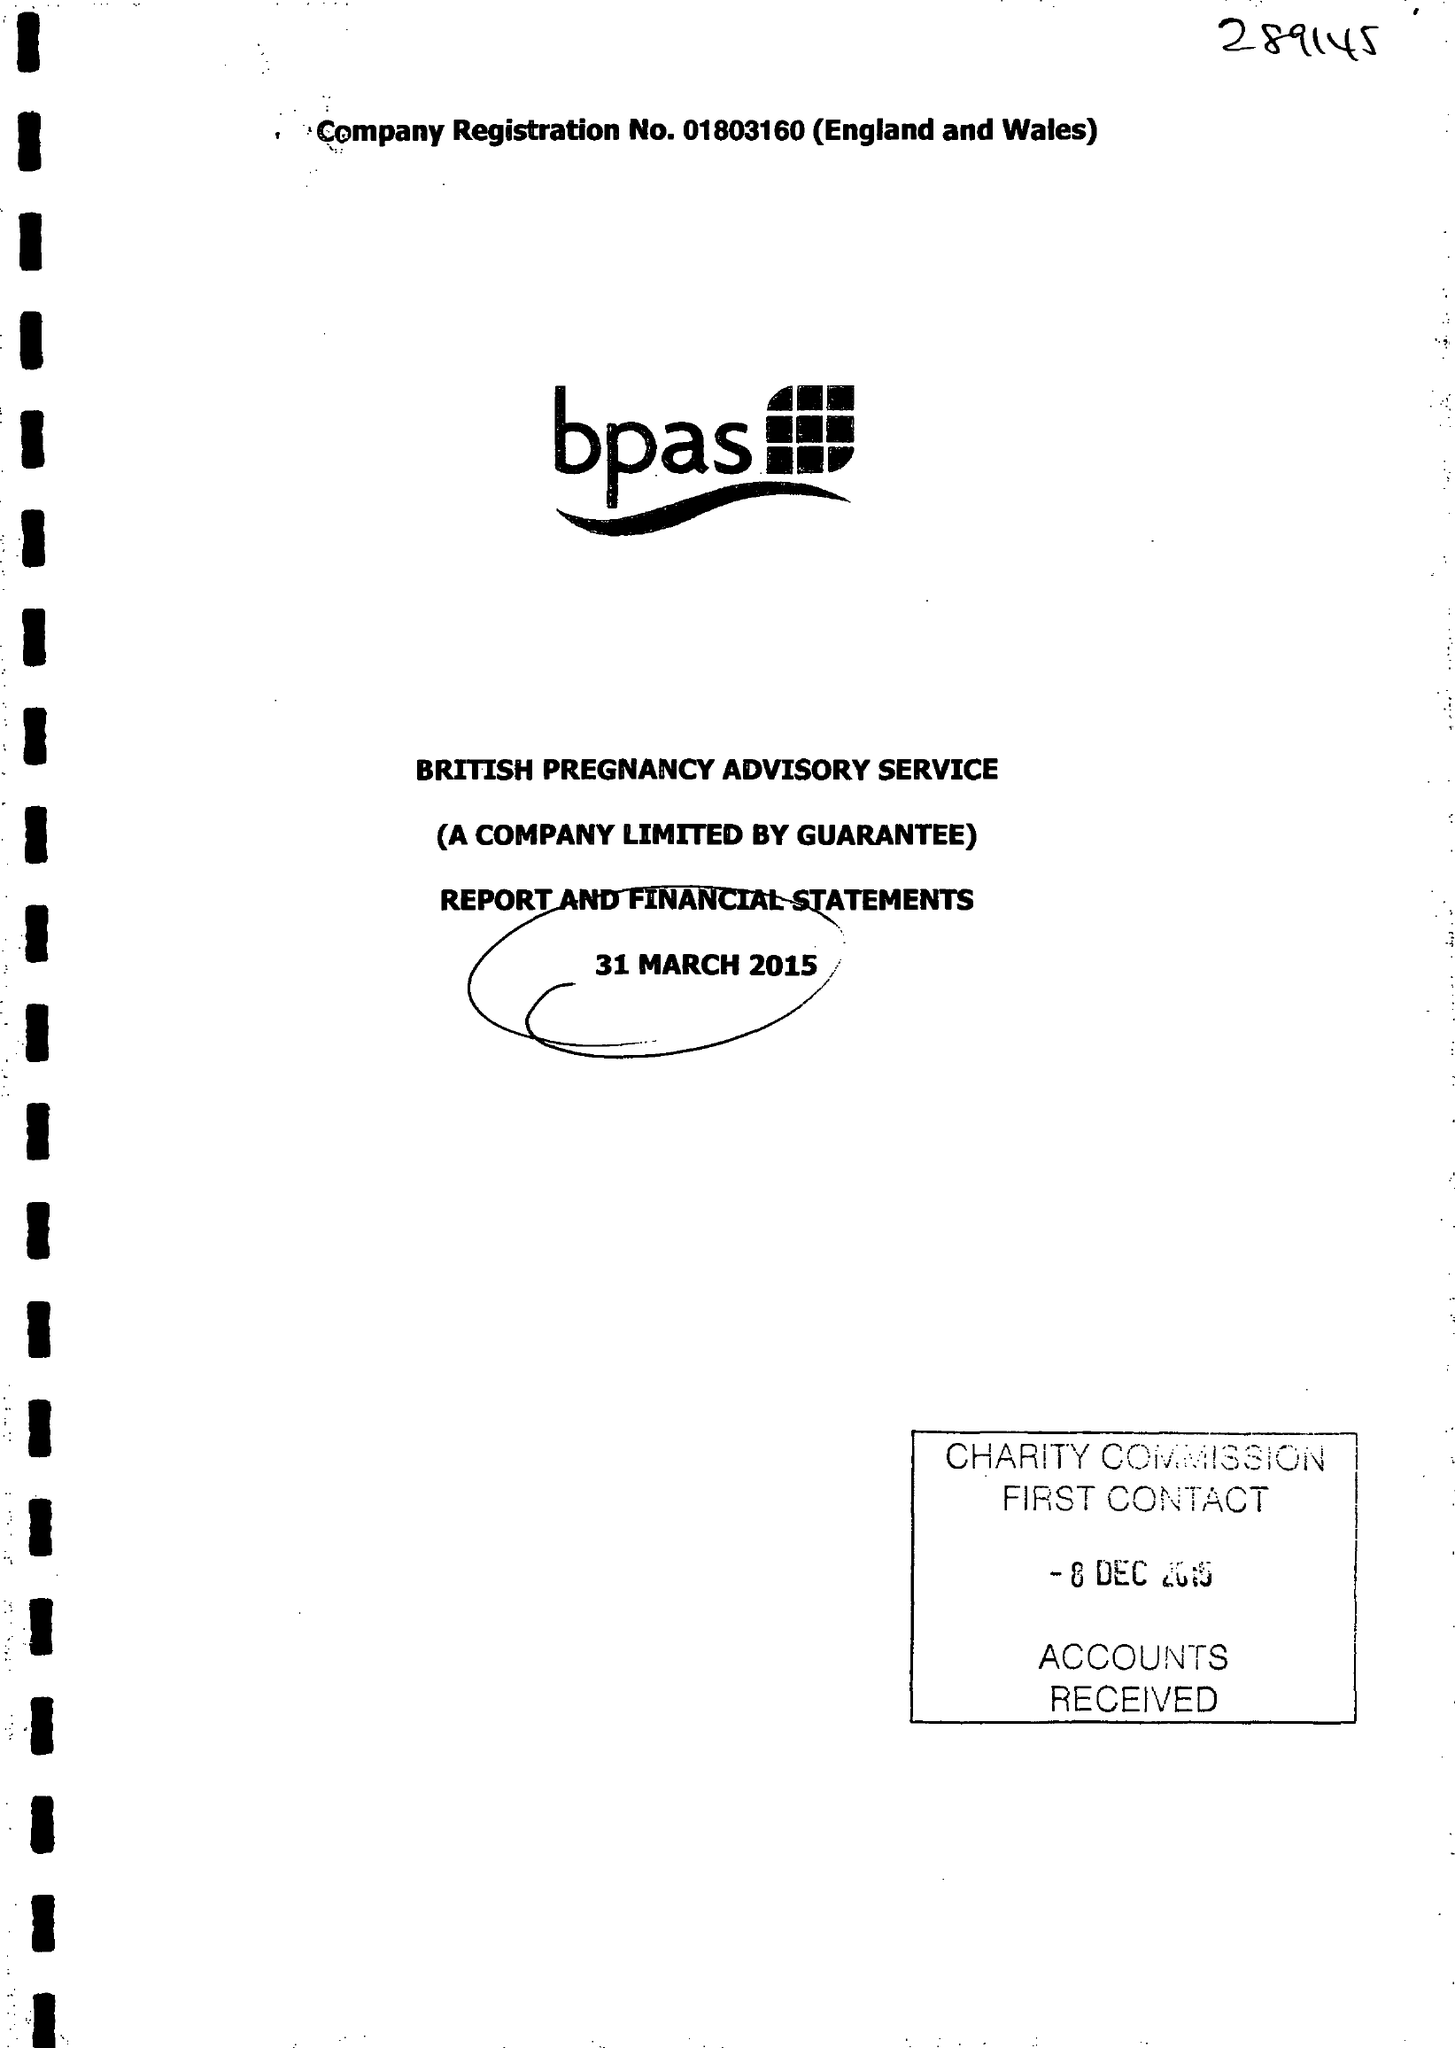What is the value for the address__street_line?
Answer the question using a single word or phrase. None 